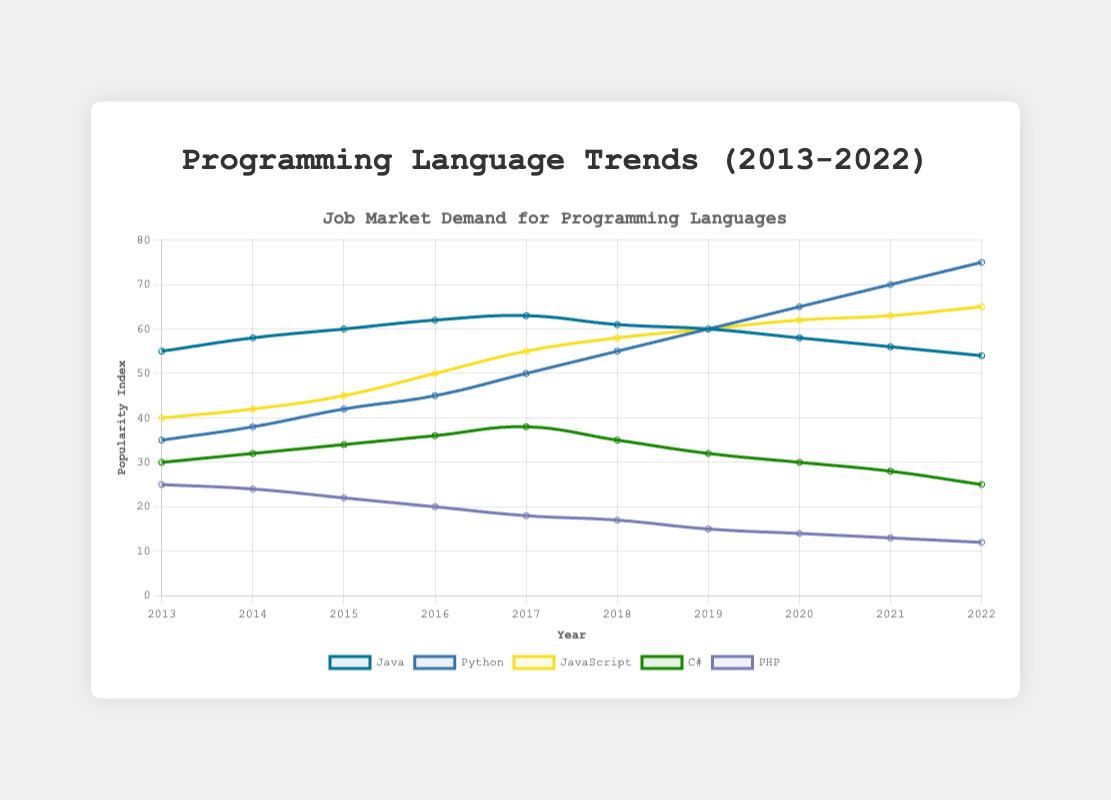What's the overall trend for Python from 2013 to 2022? From 2013 to 2022, Python's popularity index consistently increases every year, starting at 35 in 2013 and reaching 75 in 2022.
Answer: Increase Which year shows the highest popularity index for JavaScript? Reviewing the data, 2022 shows the highest index for JavaScript at 65.
Answer: 2022 How does the popularity of PHP in 2022 compare to its popularity in 2013? PHP's popularity in 2022 is 12, significantly lower than its popularity in 2013, which was 25.
Answer: Decreased Over the given decade, which year did Java reach its peak popularity and what was the index value? Java reached its peak popularity in 2017 with an index value of 63.
Answer: 2017, 63 If you sum the popularity indices of Python and Java in 2016, what value do you get? Python's index in 2016 is 45 and Java's is 62. Summing these gives 45 + 62 = 107.
Answer: 107 What can you say about the overall trend of PHP compared to Python from 2013 to 2022? While Python shows a steady increase in popularity, PHP demonstrates a consistent decline over the same period.
Answer: Opposite trends Which programming language had a consistent rise in popularity index without any drops throughout the period? Python had a consistent rise in its popularity index each year from 35 in 2013 to 75 in 2022.
Answer: Python Compare the trends of C# and JavaScript between 2013 and 2022. JavaScript shows a steady increase in popularity from 40 to 65, while C# shows a minor increase initially, but then declines from 38 in 2017 to 25 in 2022.
Answer: JavaScript increased, C# decreased In which year did Python surpass Java in popularity? In 2019, Python matched Java at 60, and by 2020, Python surpassed Java with 65 compared to Java's 58.
Answer: 2020 